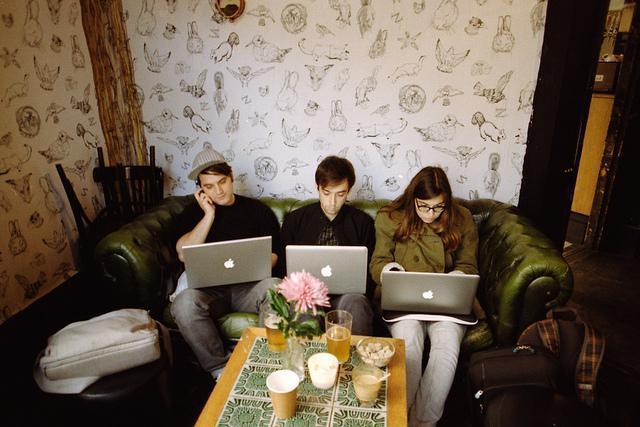How many laptops are in the picture?
Give a very brief answer. 3. How many laptops can be seen?
Give a very brief answer. 3. How many people can be seen?
Give a very brief answer. 3. 